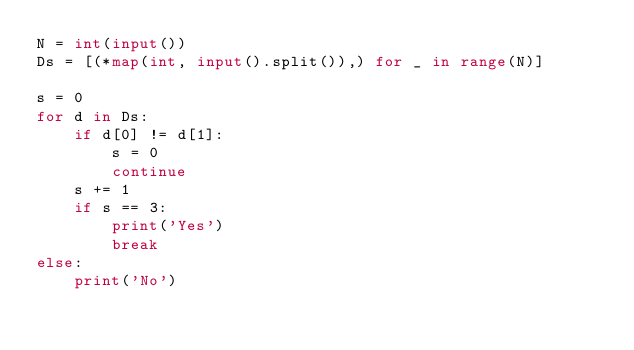<code> <loc_0><loc_0><loc_500><loc_500><_Python_>N = int(input())
Ds = [(*map(int, input().split()),) for _ in range(N)]

s = 0
for d in Ds:
    if d[0] != d[1]:
        s = 0
        continue
    s += 1
    if s == 3:
        print('Yes')
        break
else:
    print('No')
</code> 